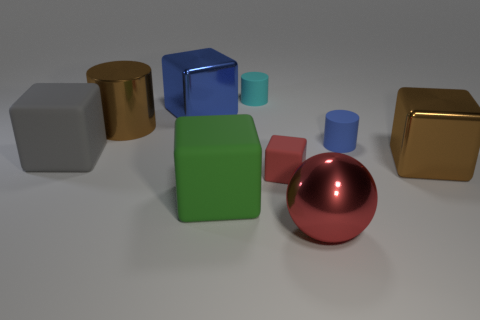The tiny rubber thing that is behind the tiny red rubber block and on the left side of the big metallic sphere has what shape?
Provide a succinct answer. Cylinder. How many blue things are the same material as the big green cube?
Ensure brevity in your answer.  1. Are there fewer large red shiny things that are on the left side of the small red thing than tiny blue rubber things?
Ensure brevity in your answer.  Yes. Is there a large green block to the left of the rubber block on the left side of the metal cylinder?
Your response must be concise. No. Is there any other thing that has the same shape as the large red metallic object?
Offer a terse response. No. Do the blue metal cube and the brown cylinder have the same size?
Offer a terse response. Yes. What is the material of the blue object in front of the brown metallic object left of the cyan rubber object behind the brown cylinder?
Your answer should be very brief. Rubber. Are there an equal number of big rubber objects on the left side of the large gray thing and small brown matte things?
Your answer should be very brief. Yes. What number of objects are small rubber cylinders or small red cubes?
Ensure brevity in your answer.  3. There is a big blue thing that is made of the same material as the big cylinder; what is its shape?
Give a very brief answer. Cube. 